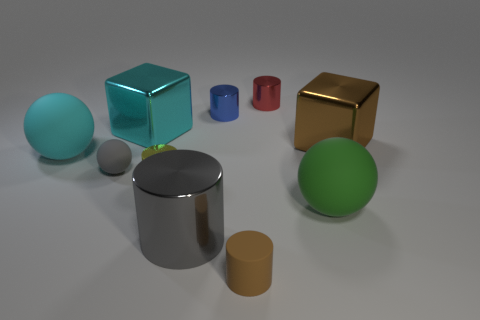Subtract all brown cylinders. How many cylinders are left? 4 Subtract all red cylinders. How many cylinders are left? 4 Subtract all green cylinders. Subtract all gray spheres. How many cylinders are left? 5 Subtract all balls. How many objects are left? 7 Subtract all cyan shiny things. Subtract all blue cylinders. How many objects are left? 8 Add 4 large green rubber objects. How many large green rubber objects are left? 5 Add 3 small brown rubber cubes. How many small brown rubber cubes exist? 3 Subtract 1 cyan blocks. How many objects are left? 9 